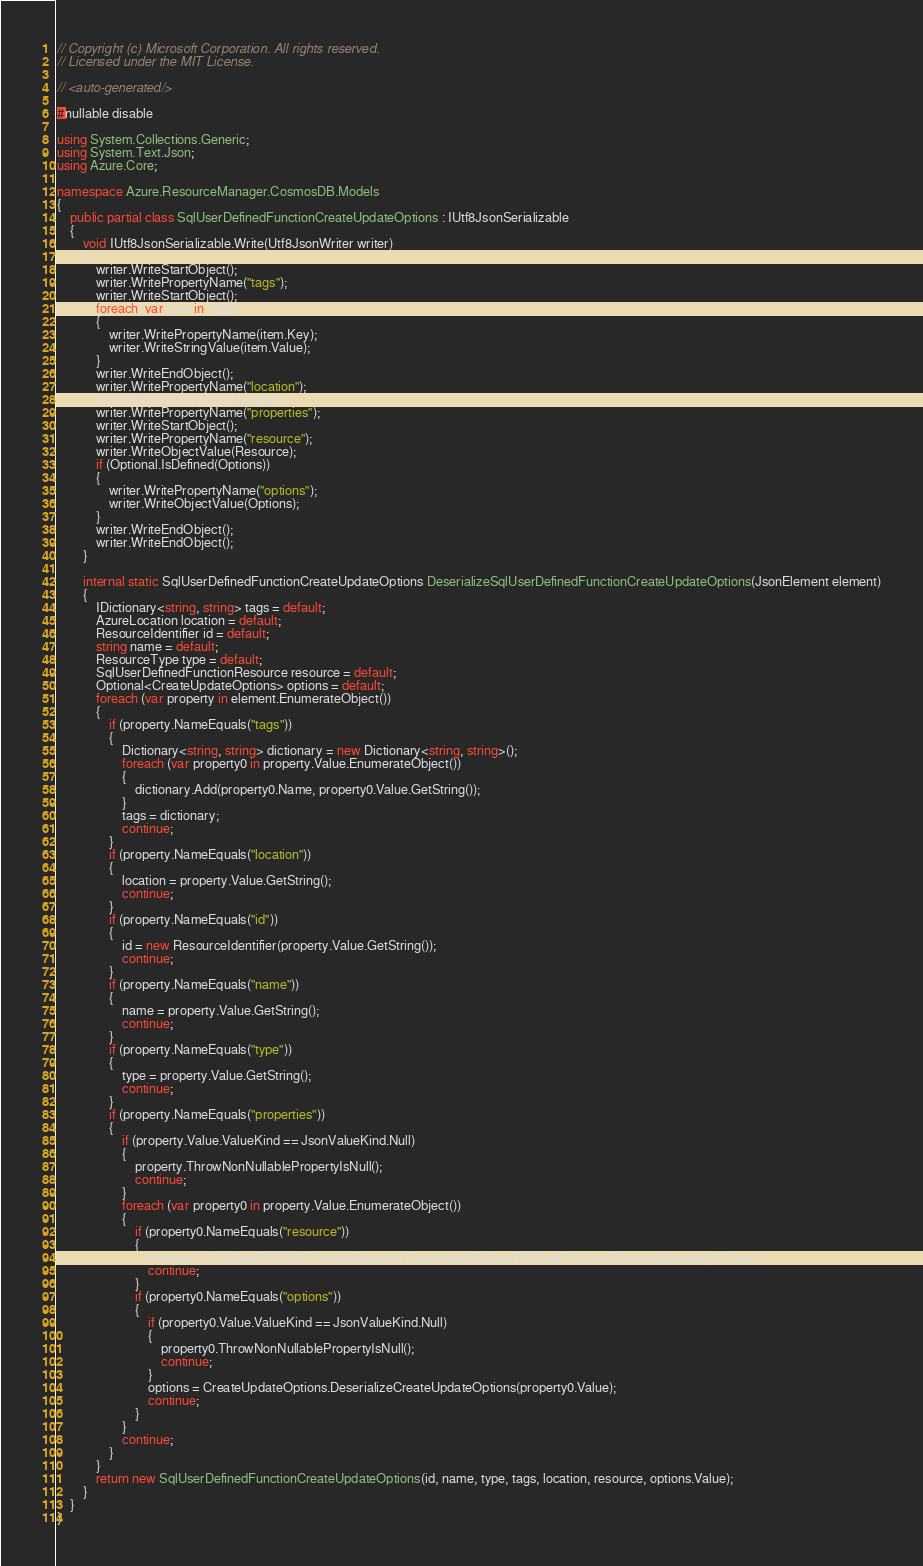Convert code to text. <code><loc_0><loc_0><loc_500><loc_500><_C#_>// Copyright (c) Microsoft Corporation. All rights reserved.
// Licensed under the MIT License.

// <auto-generated/>

#nullable disable

using System.Collections.Generic;
using System.Text.Json;
using Azure.Core;

namespace Azure.ResourceManager.CosmosDB.Models
{
    public partial class SqlUserDefinedFunctionCreateUpdateOptions : IUtf8JsonSerializable
    {
        void IUtf8JsonSerializable.Write(Utf8JsonWriter writer)
        {
            writer.WriteStartObject();
            writer.WritePropertyName("tags");
            writer.WriteStartObject();
            foreach (var item in Tags)
            {
                writer.WritePropertyName(item.Key);
                writer.WriteStringValue(item.Value);
            }
            writer.WriteEndObject();
            writer.WritePropertyName("location");
            writer.WriteStringValue(Location);
            writer.WritePropertyName("properties");
            writer.WriteStartObject();
            writer.WritePropertyName("resource");
            writer.WriteObjectValue(Resource);
            if (Optional.IsDefined(Options))
            {
                writer.WritePropertyName("options");
                writer.WriteObjectValue(Options);
            }
            writer.WriteEndObject();
            writer.WriteEndObject();
        }

        internal static SqlUserDefinedFunctionCreateUpdateOptions DeserializeSqlUserDefinedFunctionCreateUpdateOptions(JsonElement element)
        {
            IDictionary<string, string> tags = default;
            AzureLocation location = default;
            ResourceIdentifier id = default;
            string name = default;
            ResourceType type = default;
            SqlUserDefinedFunctionResource resource = default;
            Optional<CreateUpdateOptions> options = default;
            foreach (var property in element.EnumerateObject())
            {
                if (property.NameEquals("tags"))
                {
                    Dictionary<string, string> dictionary = new Dictionary<string, string>();
                    foreach (var property0 in property.Value.EnumerateObject())
                    {
                        dictionary.Add(property0.Name, property0.Value.GetString());
                    }
                    tags = dictionary;
                    continue;
                }
                if (property.NameEquals("location"))
                {
                    location = property.Value.GetString();
                    continue;
                }
                if (property.NameEquals("id"))
                {
                    id = new ResourceIdentifier(property.Value.GetString());
                    continue;
                }
                if (property.NameEquals("name"))
                {
                    name = property.Value.GetString();
                    continue;
                }
                if (property.NameEquals("type"))
                {
                    type = property.Value.GetString();
                    continue;
                }
                if (property.NameEquals("properties"))
                {
                    if (property.Value.ValueKind == JsonValueKind.Null)
                    {
                        property.ThrowNonNullablePropertyIsNull();
                        continue;
                    }
                    foreach (var property0 in property.Value.EnumerateObject())
                    {
                        if (property0.NameEquals("resource"))
                        {
                            resource = SqlUserDefinedFunctionResource.DeserializeSqlUserDefinedFunctionResource(property0.Value);
                            continue;
                        }
                        if (property0.NameEquals("options"))
                        {
                            if (property0.Value.ValueKind == JsonValueKind.Null)
                            {
                                property0.ThrowNonNullablePropertyIsNull();
                                continue;
                            }
                            options = CreateUpdateOptions.DeserializeCreateUpdateOptions(property0.Value);
                            continue;
                        }
                    }
                    continue;
                }
            }
            return new SqlUserDefinedFunctionCreateUpdateOptions(id, name, type, tags, location, resource, options.Value);
        }
    }
}
</code> 